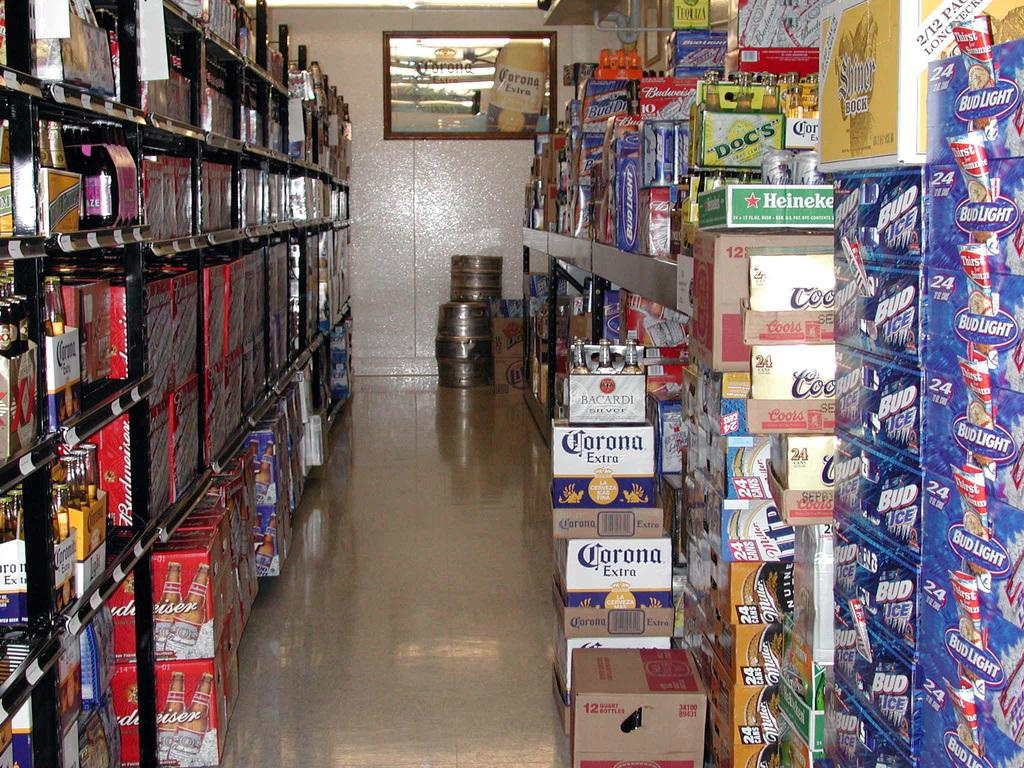What type of items can be seen in the rack in the image? There are colorful objects in the rack. What else can be seen near the rack in the image? Cardboard boxes are visible to the side. What can be seen in the background of the image? Containers and frames attached to the wall are present in the background. What type of silverware is being used by the brothers in the image? There are no brothers or silverware present in the image. 